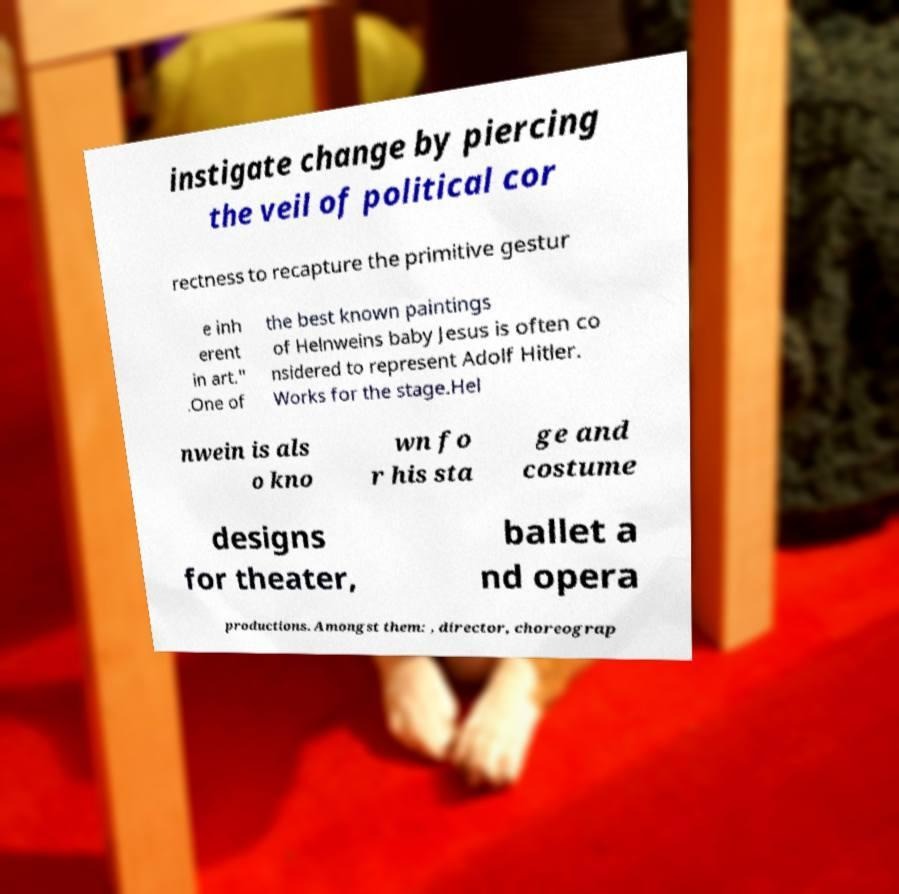What messages or text are displayed in this image? I need them in a readable, typed format. instigate change by piercing the veil of political cor rectness to recapture the primitive gestur e inh erent in art." .One of the best known paintings of Helnweins baby Jesus is often co nsidered to represent Adolf Hitler. Works for the stage.Hel nwein is als o kno wn fo r his sta ge and costume designs for theater, ballet a nd opera productions. Amongst them: , director, choreograp 